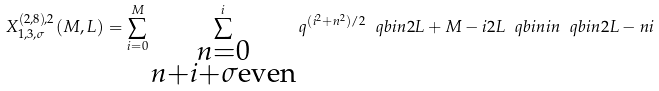Convert formula to latex. <formula><loc_0><loc_0><loc_500><loc_500>X _ { 1 , 3 , \sigma } ^ { ( 2 , 8 ) , 2 } ( M , L ) = \sum _ { i = 0 } ^ { M } \sum _ { \substack { n = 0 \\ n + i + \sigma \text {even} } } ^ { i } q ^ { ( i ^ { 2 } + n ^ { 2 } ) / 2 } \ q b i n { 2 L + M - i } { 2 L } \ q b i n { i } { n } \ q b i n { 2 L - n } { i }</formula> 